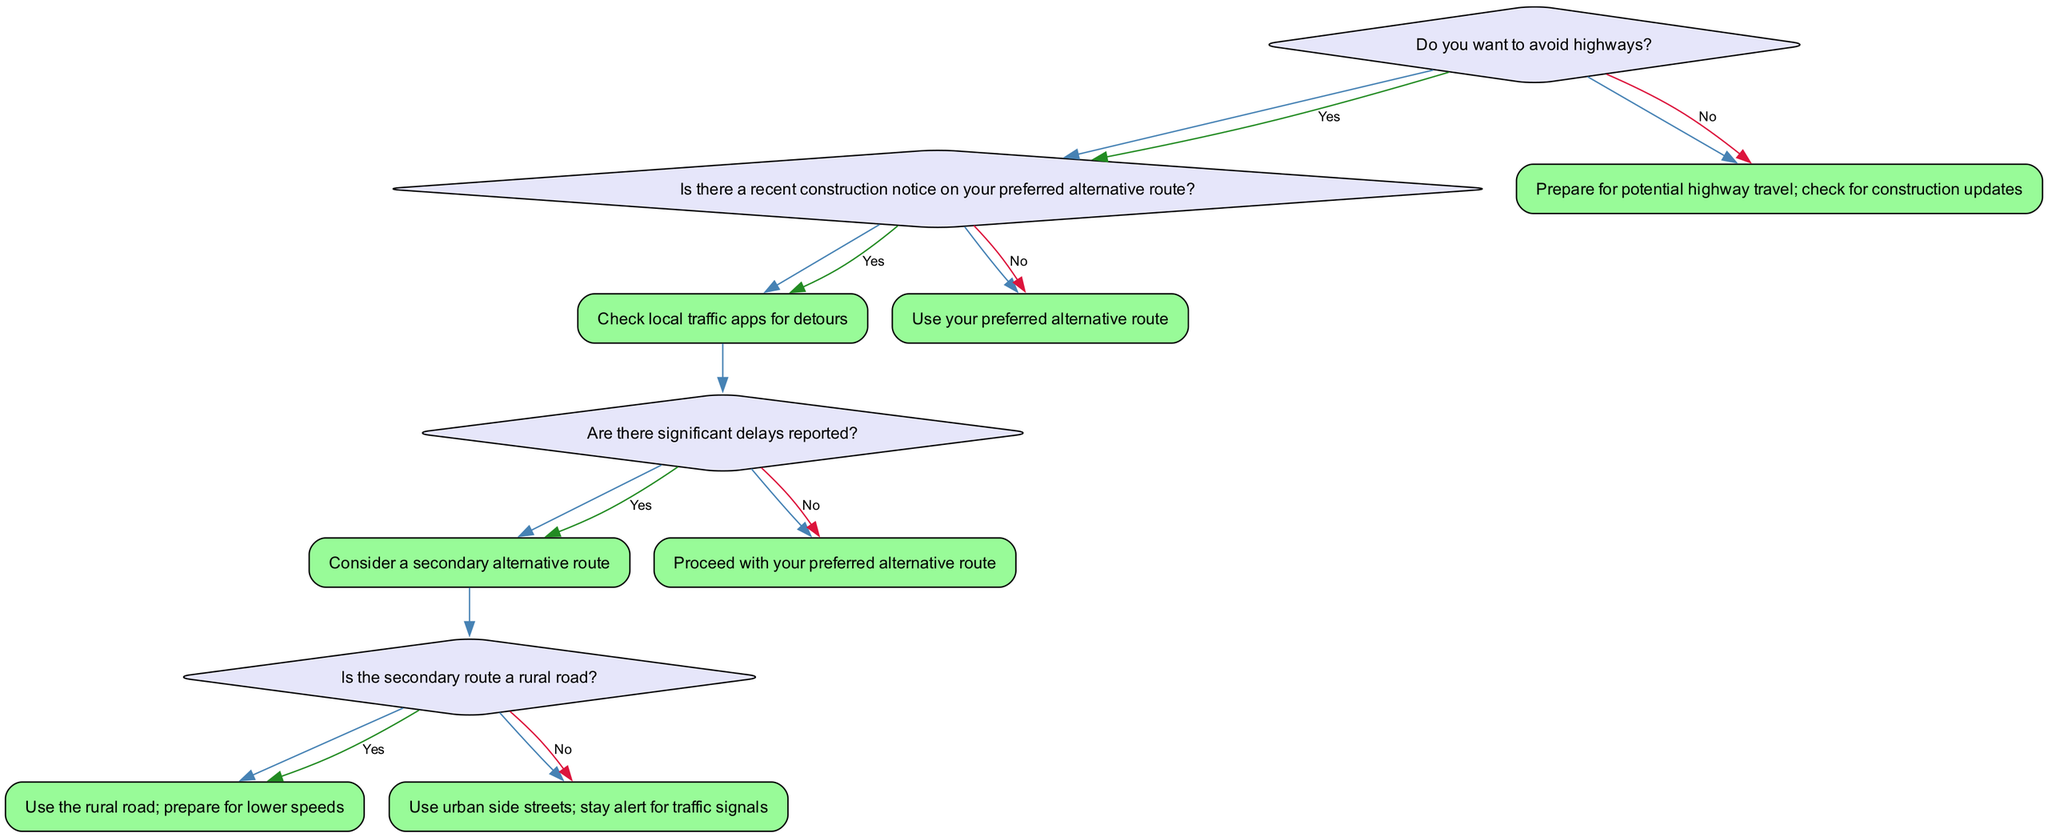What is the first question in the decision tree? The first question in the decision tree is about whether the driver wants to avoid highways.
Answer: Do you want to avoid highways? How many options does the first question provide? The first question provides two options: "Yes" and "No", representing the driver's choice to avoid highways or not.
Answer: 2 If the answer to the first question is "Yes," what is the next question asked? When the answer to the first question is "Yes," the next question asked is regarding whether there is a recent construction notice on the preferred alternative route.
Answer: Is there a recent construction notice on your preferred alternative route? What happens if there are significant delays reported? If there are significant delays reported, the action suggests considering a secondary alternative route.
Answer: Consider a secondary alternative route What action is taken if the secondary route is a rural road? If the secondary route is identified as a rural road, the action is to use that rural road and prepare for lower speeds.
Answer: Use the rural road; prepare for lower speeds What is the final action for the "No" answer to the second question about construction? If there is no recent construction notice, the final action is to use the preferred alternative route.
Answer: Use your preferred alternative route What is the outcome if the driver's answer to the first question is "No"? If the answer to the first question is "No," the action to be taken is to prepare for potential highway travel and check for construction updates.
Answer: Prepare for potential highway travel; check for construction updates What does the decision tree ultimately guide the driver towards? The decision tree guides the driver toward a series of actions based on their preference to avoid highways and the conditions of alternate routes.
Answer: Actions based on highway avoidance preferences 